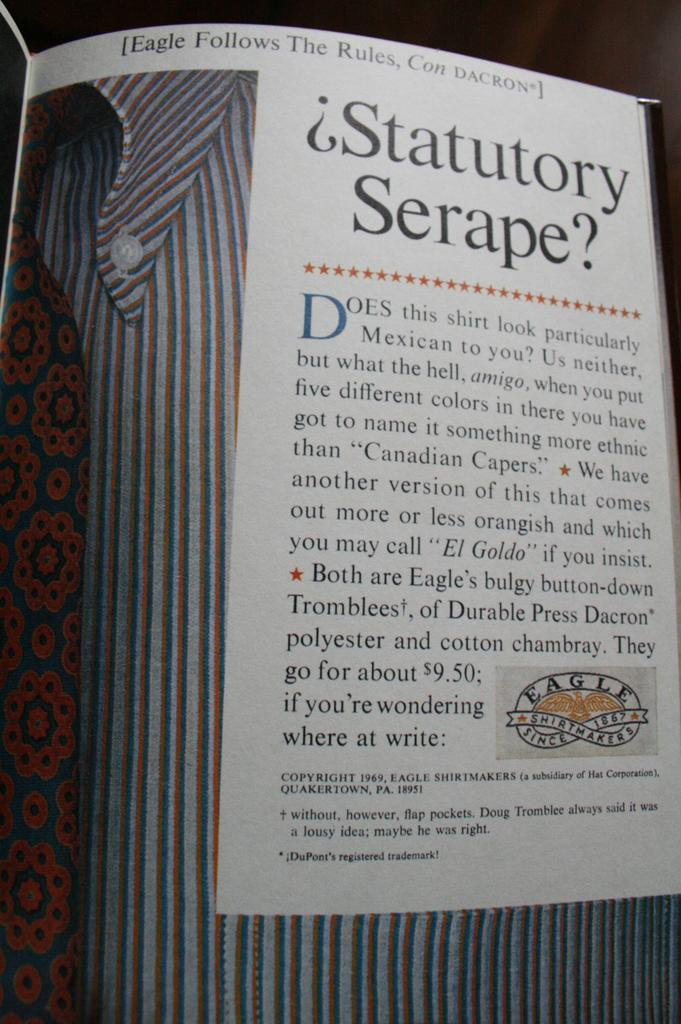<image>
Summarize the visual content of the image. the word serape that is on an item 